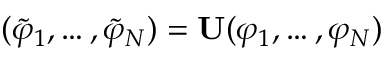Convert formula to latex. <formula><loc_0><loc_0><loc_500><loc_500>( \widetilde { \varphi } _ { 1 } , \dots , \widetilde { \varphi } _ { N } ) = U ( \varphi _ { 1 } , \dots , \varphi _ { N } )</formula> 